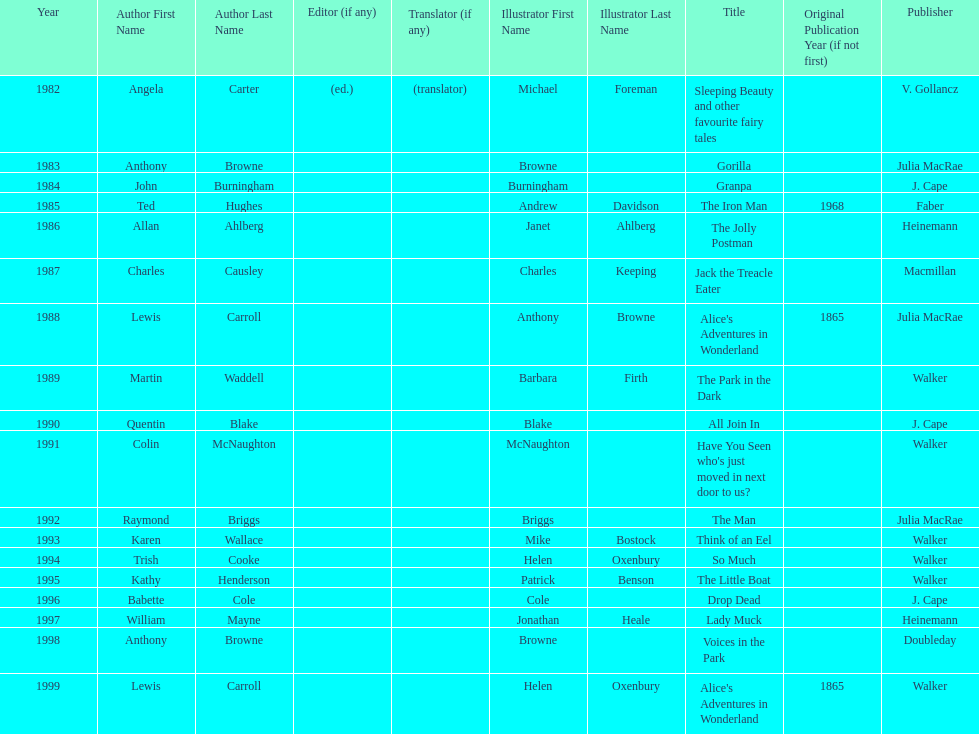How many titles had the same author listed as the illustrator? 7. 